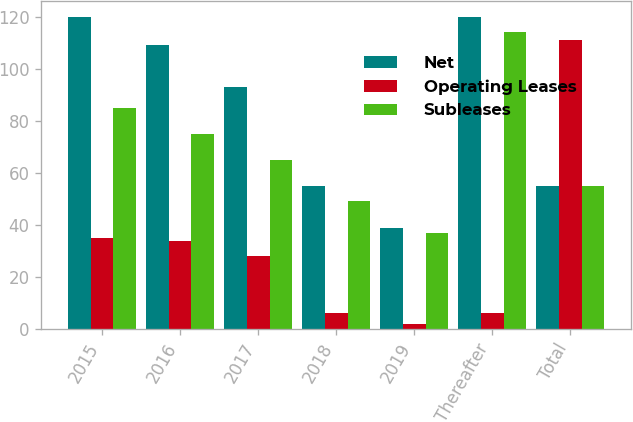<chart> <loc_0><loc_0><loc_500><loc_500><stacked_bar_chart><ecel><fcel>2015<fcel>2016<fcel>2017<fcel>2018<fcel>2019<fcel>Thereafter<fcel>Total<nl><fcel>Net<fcel>120<fcel>109<fcel>93<fcel>55<fcel>39<fcel>120<fcel>55<nl><fcel>Operating Leases<fcel>35<fcel>34<fcel>28<fcel>6<fcel>2<fcel>6<fcel>111<nl><fcel>Subleases<fcel>85<fcel>75<fcel>65<fcel>49<fcel>37<fcel>114<fcel>55<nl></chart> 